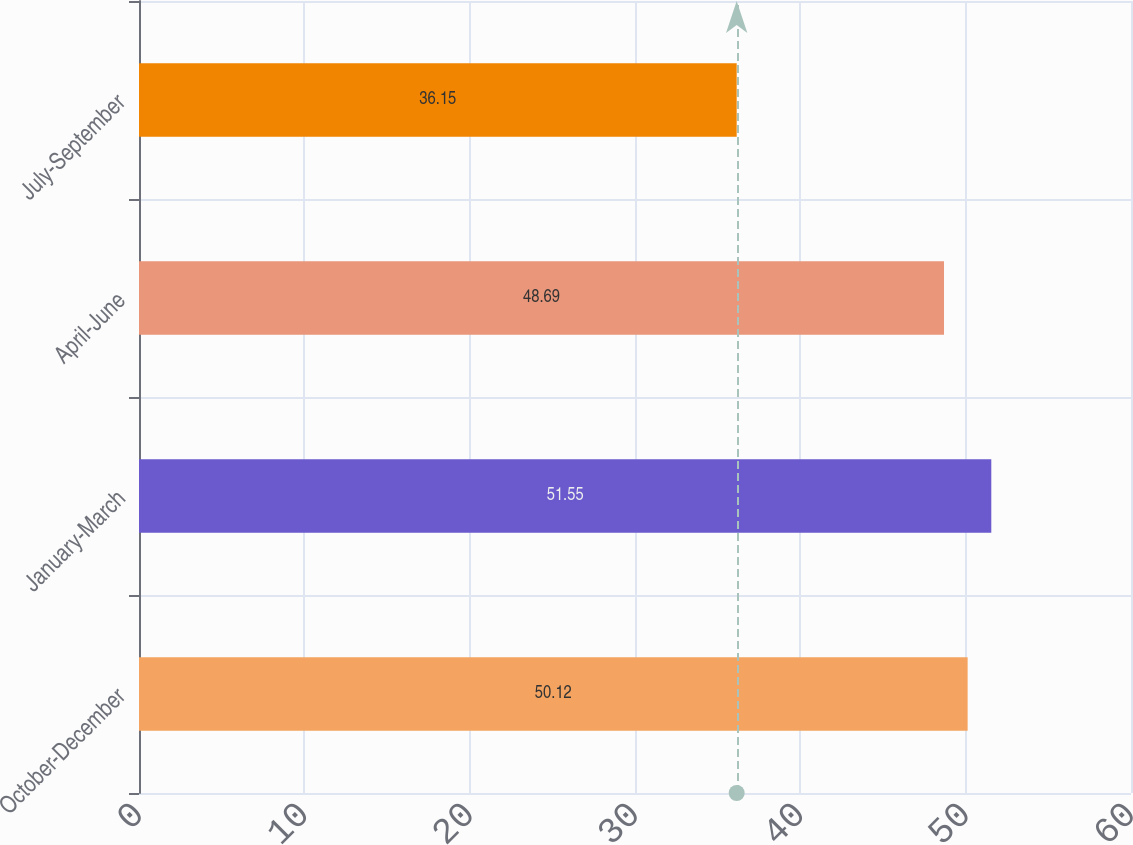Convert chart to OTSL. <chart><loc_0><loc_0><loc_500><loc_500><bar_chart><fcel>October-December<fcel>January-March<fcel>April-June<fcel>July-September<nl><fcel>50.12<fcel>51.55<fcel>48.69<fcel>36.15<nl></chart> 